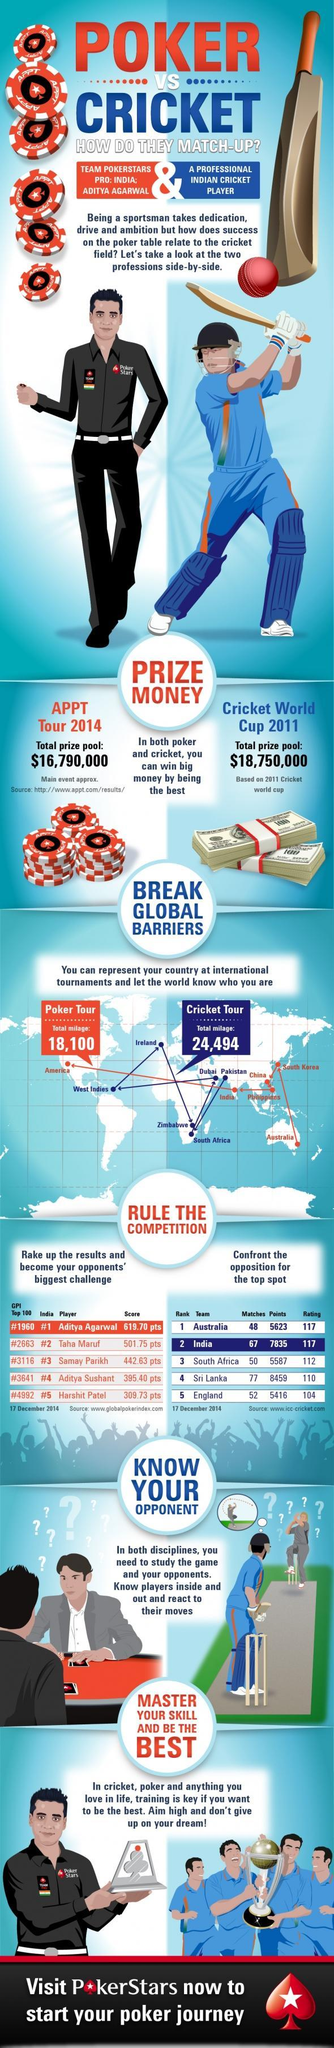Who is the best Indian poker player after Aditya Agarwal as of December 17, 2014?
Answer the question with a short phrase. Taha Maruf What is the total prize pool for 2011 Cricket World Cup? $18,750,000 Which team has the top ICC ranking as of December 17, 2014? Australia What is the total number of match points scored by India as of December 17, 2014? 7835 What is the ICC rating of Sri Lanka as of December 17, 2014? 110 